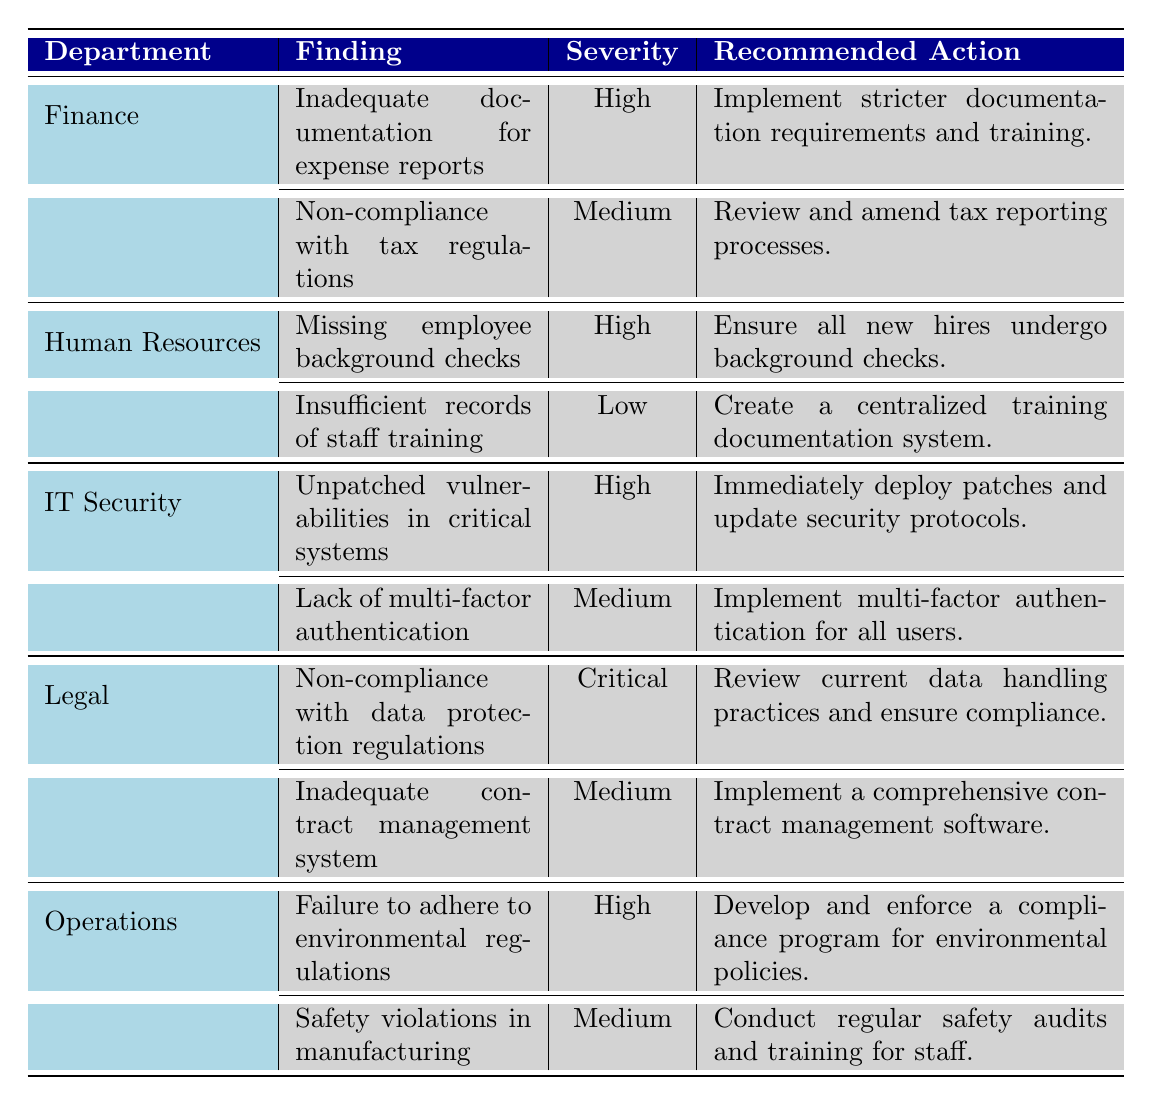What is the severity level of the finding "Inadequate documentation for expense reports"? The finding "Inadequate documentation for expense reports" is listed under the Finance department, and its severity level is specified as "High" in the table.
Answer: High Which department has the most critical finding? The Legal department has the finding "Non-compliance with data protection regulations," which is noted as "Critical" in the severity column.
Answer: Legal How many findings in total are listed for the IT Security department? The IT Security department has two findings listed: "Unpatched vulnerabilities in critical systems" and "Lack of multi-factor authentication." Thus, the total number of findings is 2.
Answer: 2 Are there any findings with a "Low" severity rating? Yes, the Human Resources department has a finding labeled "Insufficient records of staff training," which is categorized as "Low" severity.
Answer: Yes What is the recommended action for the finding with "Critical" severity? The recommended action for the finding with "Critical" severity, which is "Non-compliance with data protection regulations," is to "Review current data handling practices and ensure compliance." This is found in the Legal department's section of the table.
Answer: Review current data handling practices and ensure compliance Which department has the highest severity finding and what is it? The Legal department has the highest severity finding, which is "Non-compliance with data protection regulations," rated as "Critical." This information can be identified by comparing severity ratings across all departments.
Answer: Legal, Non-compliance with data protection regulations, Critical How many "High" severity findings are there across all departments? The "High" severity findings can be identified in the table: Finance has 1, Human Resources has 1, IT Security has 1, Legal has 0, and Operations has 1. Summing these gives a total of 4 "High" severity findings.
Answer: 4 Is there any finding in the Operations department with a severity of "Medium"? Yes, in the Operations department, there is a finding called "Safety violations in manufacturing," which is rated as "Medium." This information can be found directly in the Operations section of the table.
Answer: Yes What would be the next step if the finding "Unpatched vulnerabilities in critical systems" is not addressed? If the finding "Unpatched vulnerabilities in critical systems" is not addressed, the severity level is "High," indicating that this could lead to significant security risks, including potential data breaches. Thus, it is essential to implement the recommended action of deploying patches and updating security protocols before serious consequences occur.
Answer: Significant security risks 